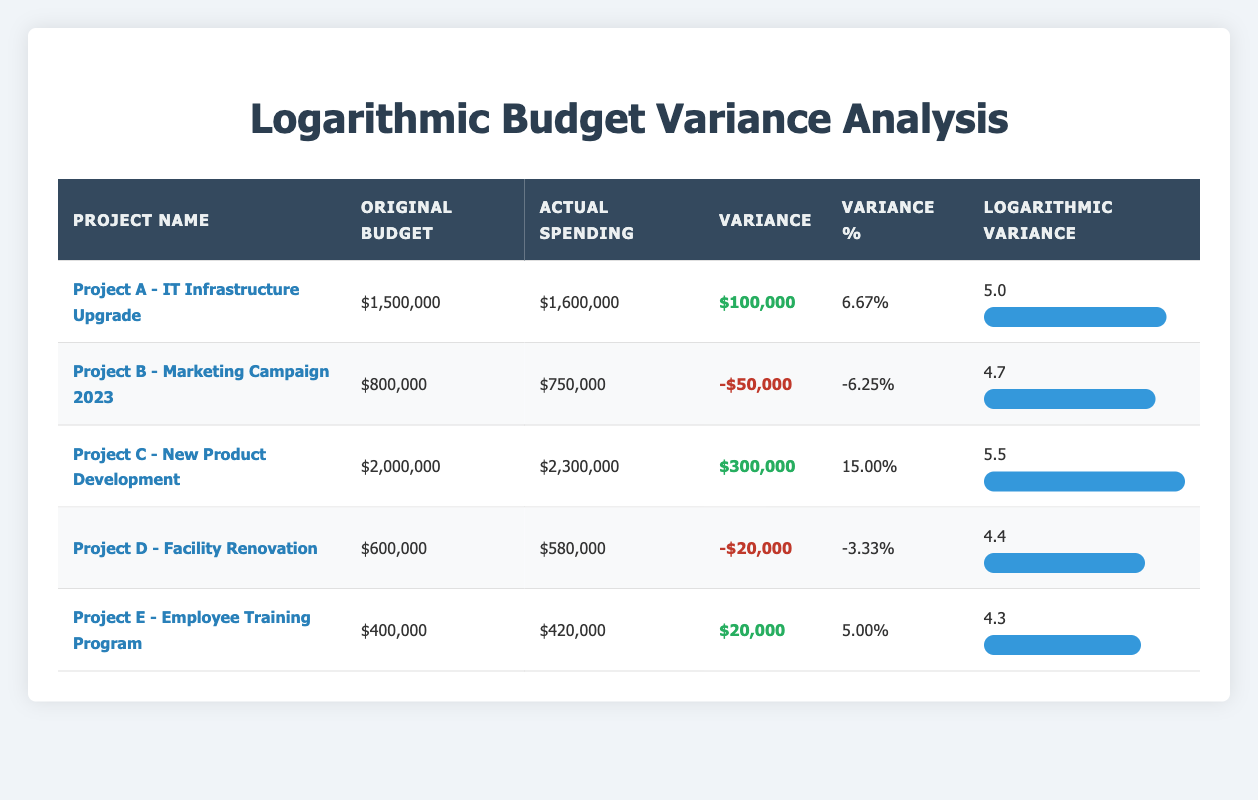What is the project with the highest budget variance? The data shows that Project C - New Product Development has the highest budget variance of $300,000, which is located in the "Variance" column.
Answer: Project C - New Product Development What is the total original budget for all projects listed? By summing the original budgets: 1,500,000 + 800,000 + 2,000,000 + 600,000 + 400,000 = 5,300,000.
Answer: 5,300,000 Did any project come in under budget? The table shows two projects with negative variances: Project B - Marketing Campaign 2023 with a variance of -$50,000 and Project D - Facility Renovation with a variance of -$20,000, meaning both projects were under budget.
Answer: Yes What is the variance percentage for Project A? The variance percentage for Project A - IT Infrastructure Upgrade is 6.67%, as indicated directly in the corresponding column.
Answer: 6.67% Which project had the least actual spending compared to its budget? Comparing the variances for each project, Project D - Facility Renovation had actual spending of $580,000 against its budget of $600,000, resulting in the smallest difference.
Answer: Project D - Facility Renovation Calculate the average logarithmic variance for all projects. Summing all logarithmic variances gives: 5.0 + 4.7 + 5.5 + 4.4 + 4.3 = 24.0, and dividing by 5 (the number of projects) results in an average of 24.0 / 5 = 4.8.
Answer: 4.8 Is the actual spending for Project E higher than its original budget? Project E - Employee Training Program had an actual spending of $420,000, which is greater than its original budget of $400,000, indicating it exceeded the budget.
Answer: Yes Which project had the highest variance percentage? Looking at the variance percentages, Project C - New Product Development is marked at 15.0%, the highest when compared to other projects listed.
Answer: Project C - New Product Development 